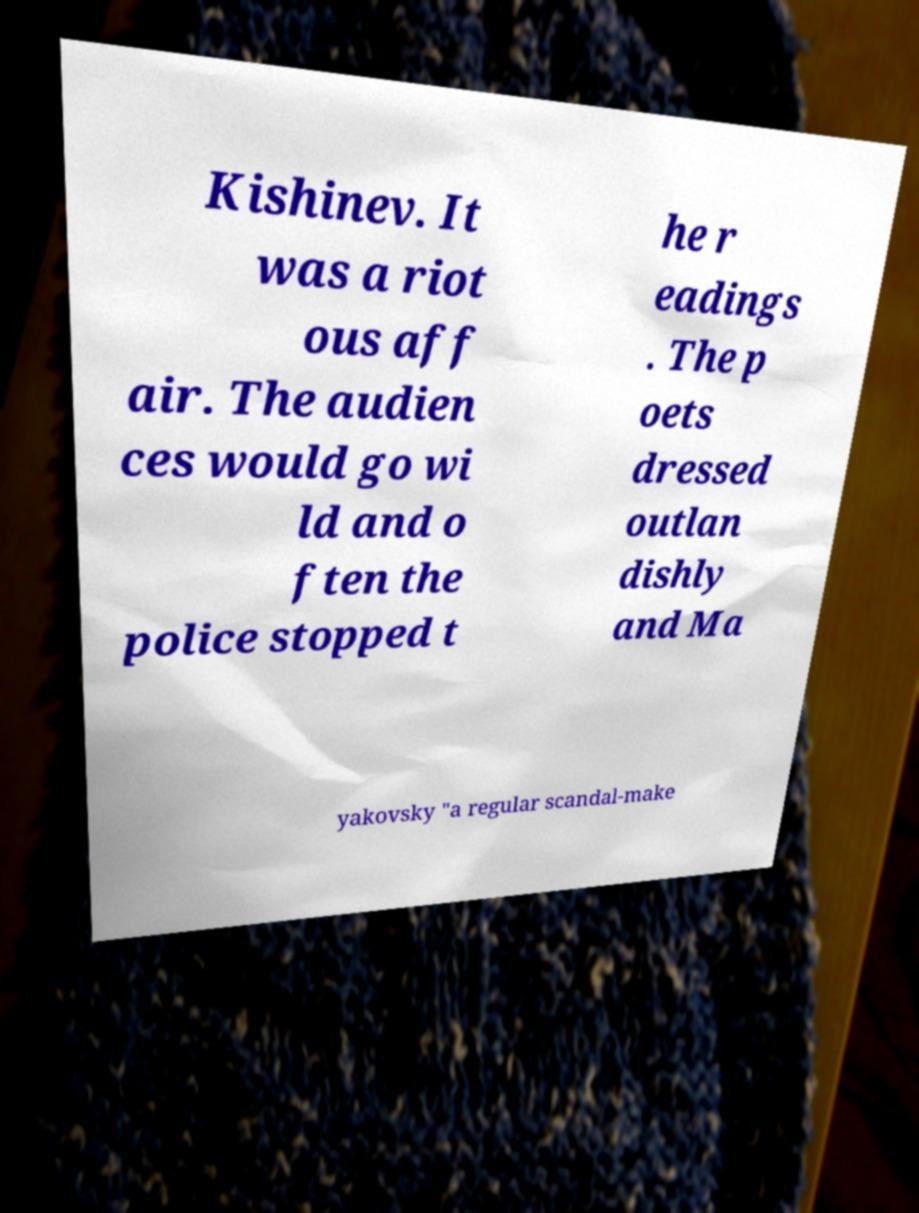Could you assist in decoding the text presented in this image and type it out clearly? Kishinev. It was a riot ous aff air. The audien ces would go wi ld and o ften the police stopped t he r eadings . The p oets dressed outlan dishly and Ma yakovsky "a regular scandal-make 